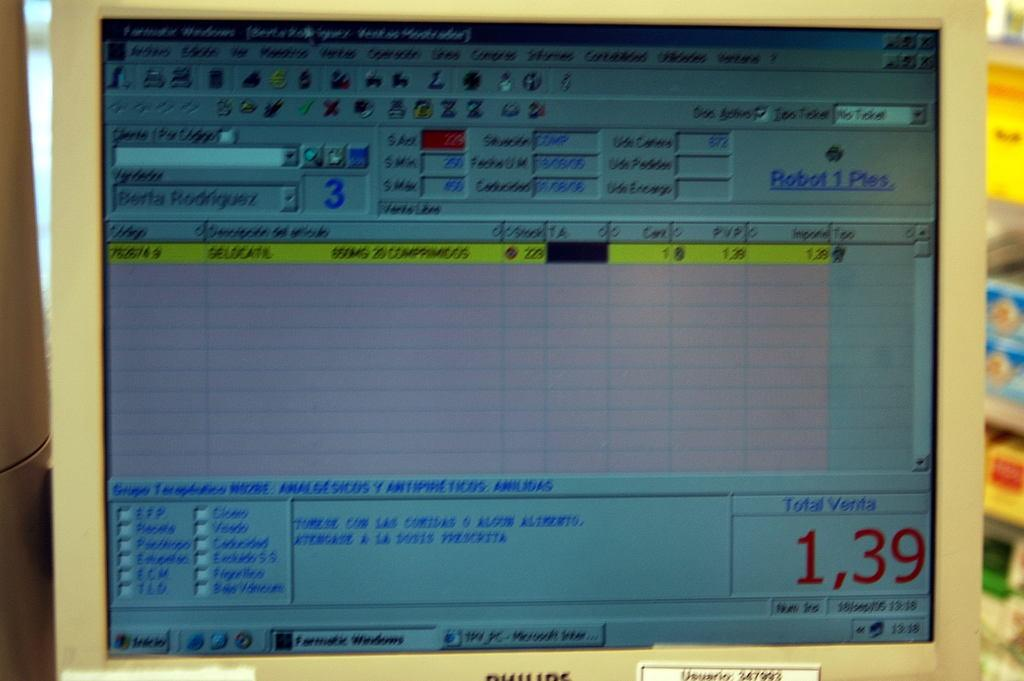<image>
Write a terse but informative summary of the picture. Computer screen that shots the Total Venta at 1,39. 